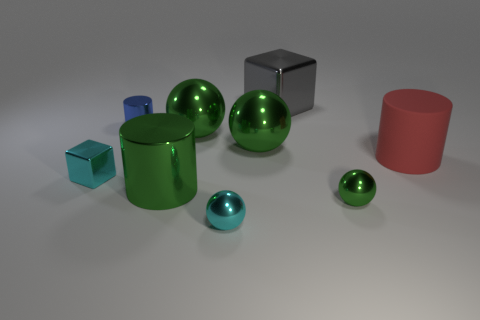The large matte thing is what color?
Give a very brief answer. Red. What shape is the large green metal object in front of the large cylinder to the right of the gray cube?
Keep it short and to the point. Cylinder. Is there a small cylinder made of the same material as the gray cube?
Ensure brevity in your answer.  Yes. Does the cylinder on the right side of the gray object have the same size as the small green shiny thing?
Provide a short and direct response. No. What number of cyan things are either tiny matte cylinders or blocks?
Provide a short and direct response. 1. What material is the big cylinder left of the small cyan sphere?
Ensure brevity in your answer.  Metal. How many large green objects are to the left of the tiny metallic thing right of the cyan shiny ball?
Make the answer very short. 3. How many big gray shiny objects are the same shape as the small green thing?
Provide a succinct answer. 0. How many shiny objects are there?
Offer a terse response. 8. There is a shiny cylinder that is in front of the red rubber cylinder; what color is it?
Provide a short and direct response. Green. 